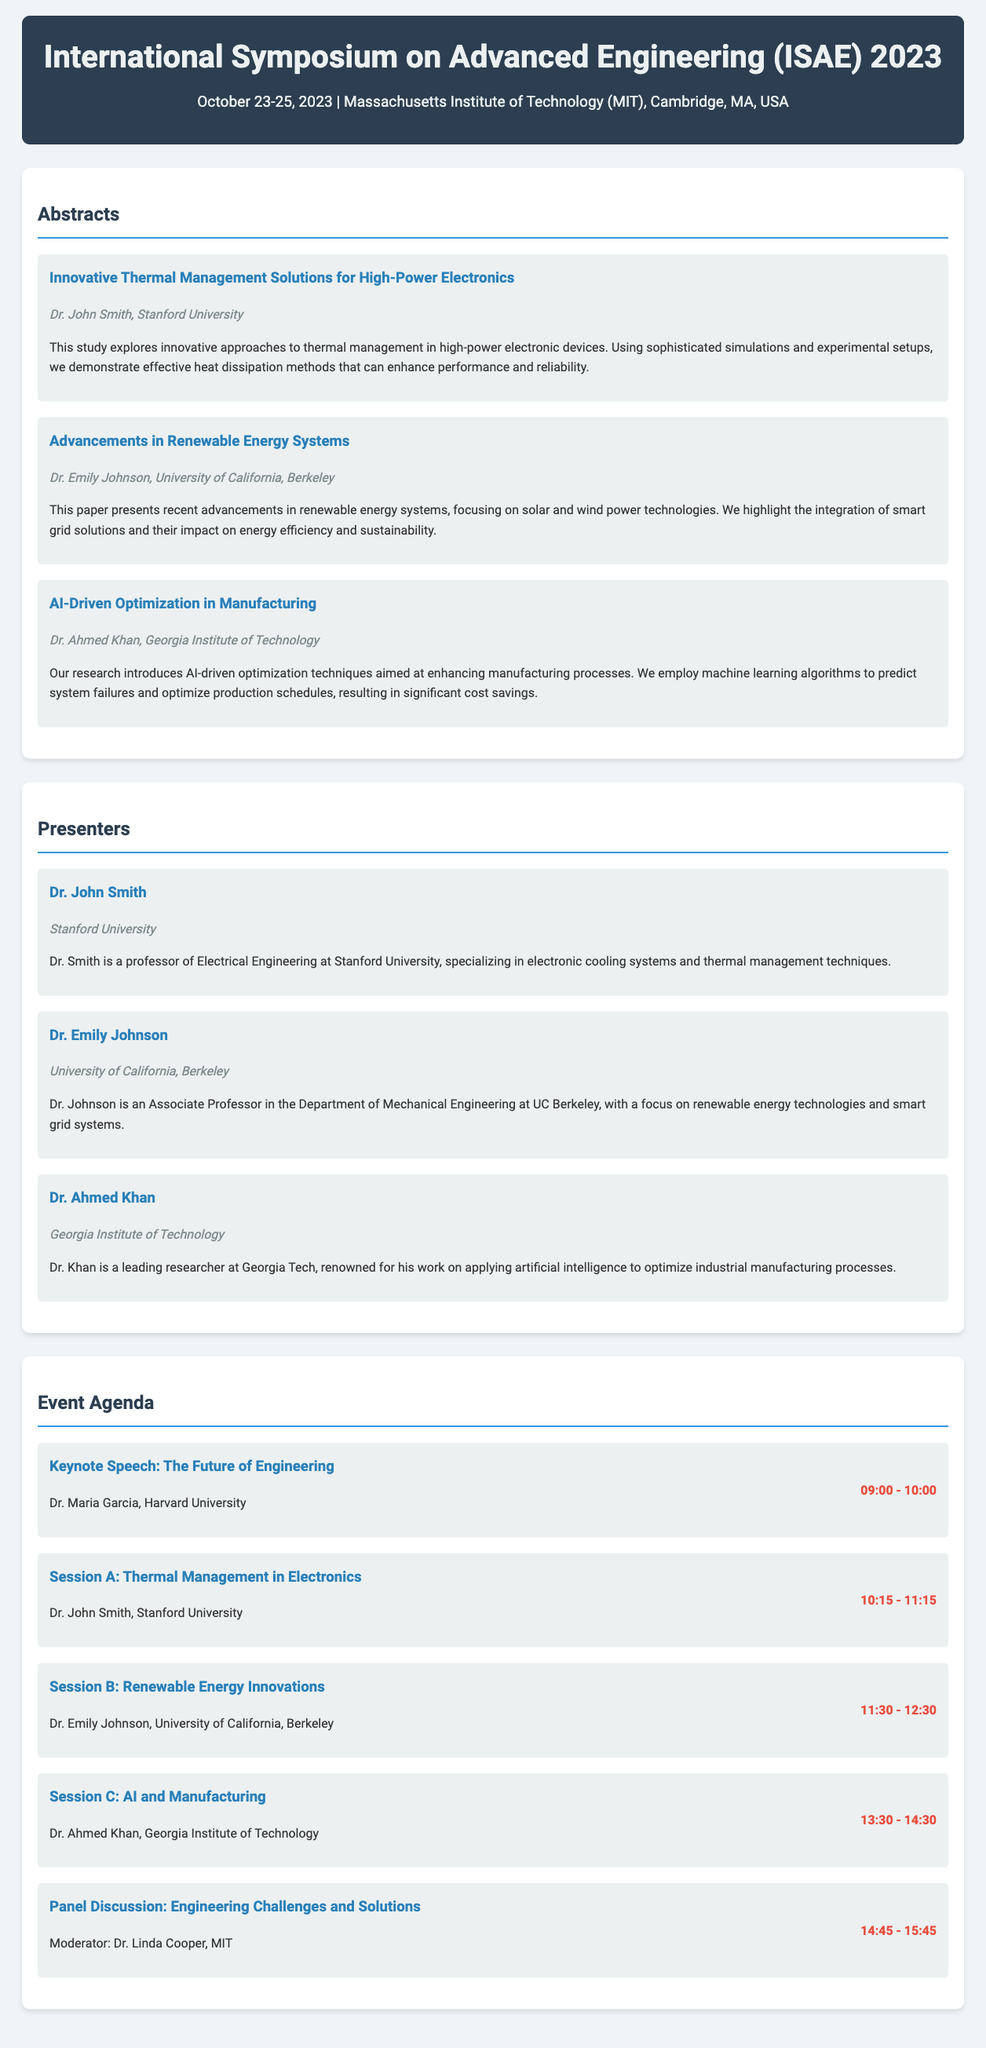what is the title of the conference? The title of the conference is mentioned in the header of the document, which is "International Symposium on Advanced Engineering (ISAE) 2023."
Answer: International Symposium on Advanced Engineering (ISAE) 2023 who is the presenter of the first abstract? The first abstract is titled "Innovative Thermal Management Solutions for High-Power Electronics," and its presenter is Dr. John Smith.
Answer: Dr. John Smith what university is Dr. Emily Johnson affiliated with? Dr. Emily Johnson's affiliation is provided in the presenter section of the document, stating she is from the University of California, Berkeley.
Answer: University of California, Berkeley how many sessions are listed in the event agenda? The event agenda section consists of five agenda items, indicating the number of sessions listed.
Answer: 5 what time does the keynote speech start? The time for the keynote speech is stated in the event agenda as starting at "09:00."
Answer: 09:00 what is the main topic of the panel discussion? The topic of the panel discussion is specified as "Engineering Challenges and Solutions" in the agenda section.
Answer: Engineering Challenges and Solutions which presenter specializes in AI and manufacturing? The presenter specializing in AI and manufacturing is identified in the document as Dr. Ahmed Khan.
Answer: Dr. Ahmed Khan what is the date range of the conference? The date range of the conference is provided in the conference information section, which is from October 23 to October 25, 2023.
Answer: October 23-25, 2023 